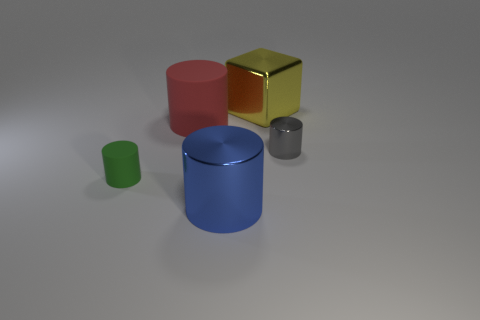What number of things are either things that are to the right of the small green thing or big metal objects?
Your answer should be very brief. 4. Is there a green matte cylinder of the same size as the gray cylinder?
Keep it short and to the point. Yes. Are there fewer large metal balls than yellow blocks?
Make the answer very short. Yes. What number of spheres are large metallic things or large rubber things?
Offer a very short reply. 0. There is a cylinder that is to the right of the big red cylinder and behind the big blue thing; what size is it?
Your answer should be compact. Small. Is the number of gray metal objects that are left of the red rubber cylinder less than the number of big metal objects?
Ensure brevity in your answer.  Yes. Is the material of the tiny green thing the same as the large blue cylinder?
Keep it short and to the point. No. What number of objects are either brown things or yellow objects?
Make the answer very short. 1. How many cylinders are made of the same material as the cube?
Make the answer very short. 2. What is the size of the gray metal object that is the same shape as the big blue shiny object?
Ensure brevity in your answer.  Small. 